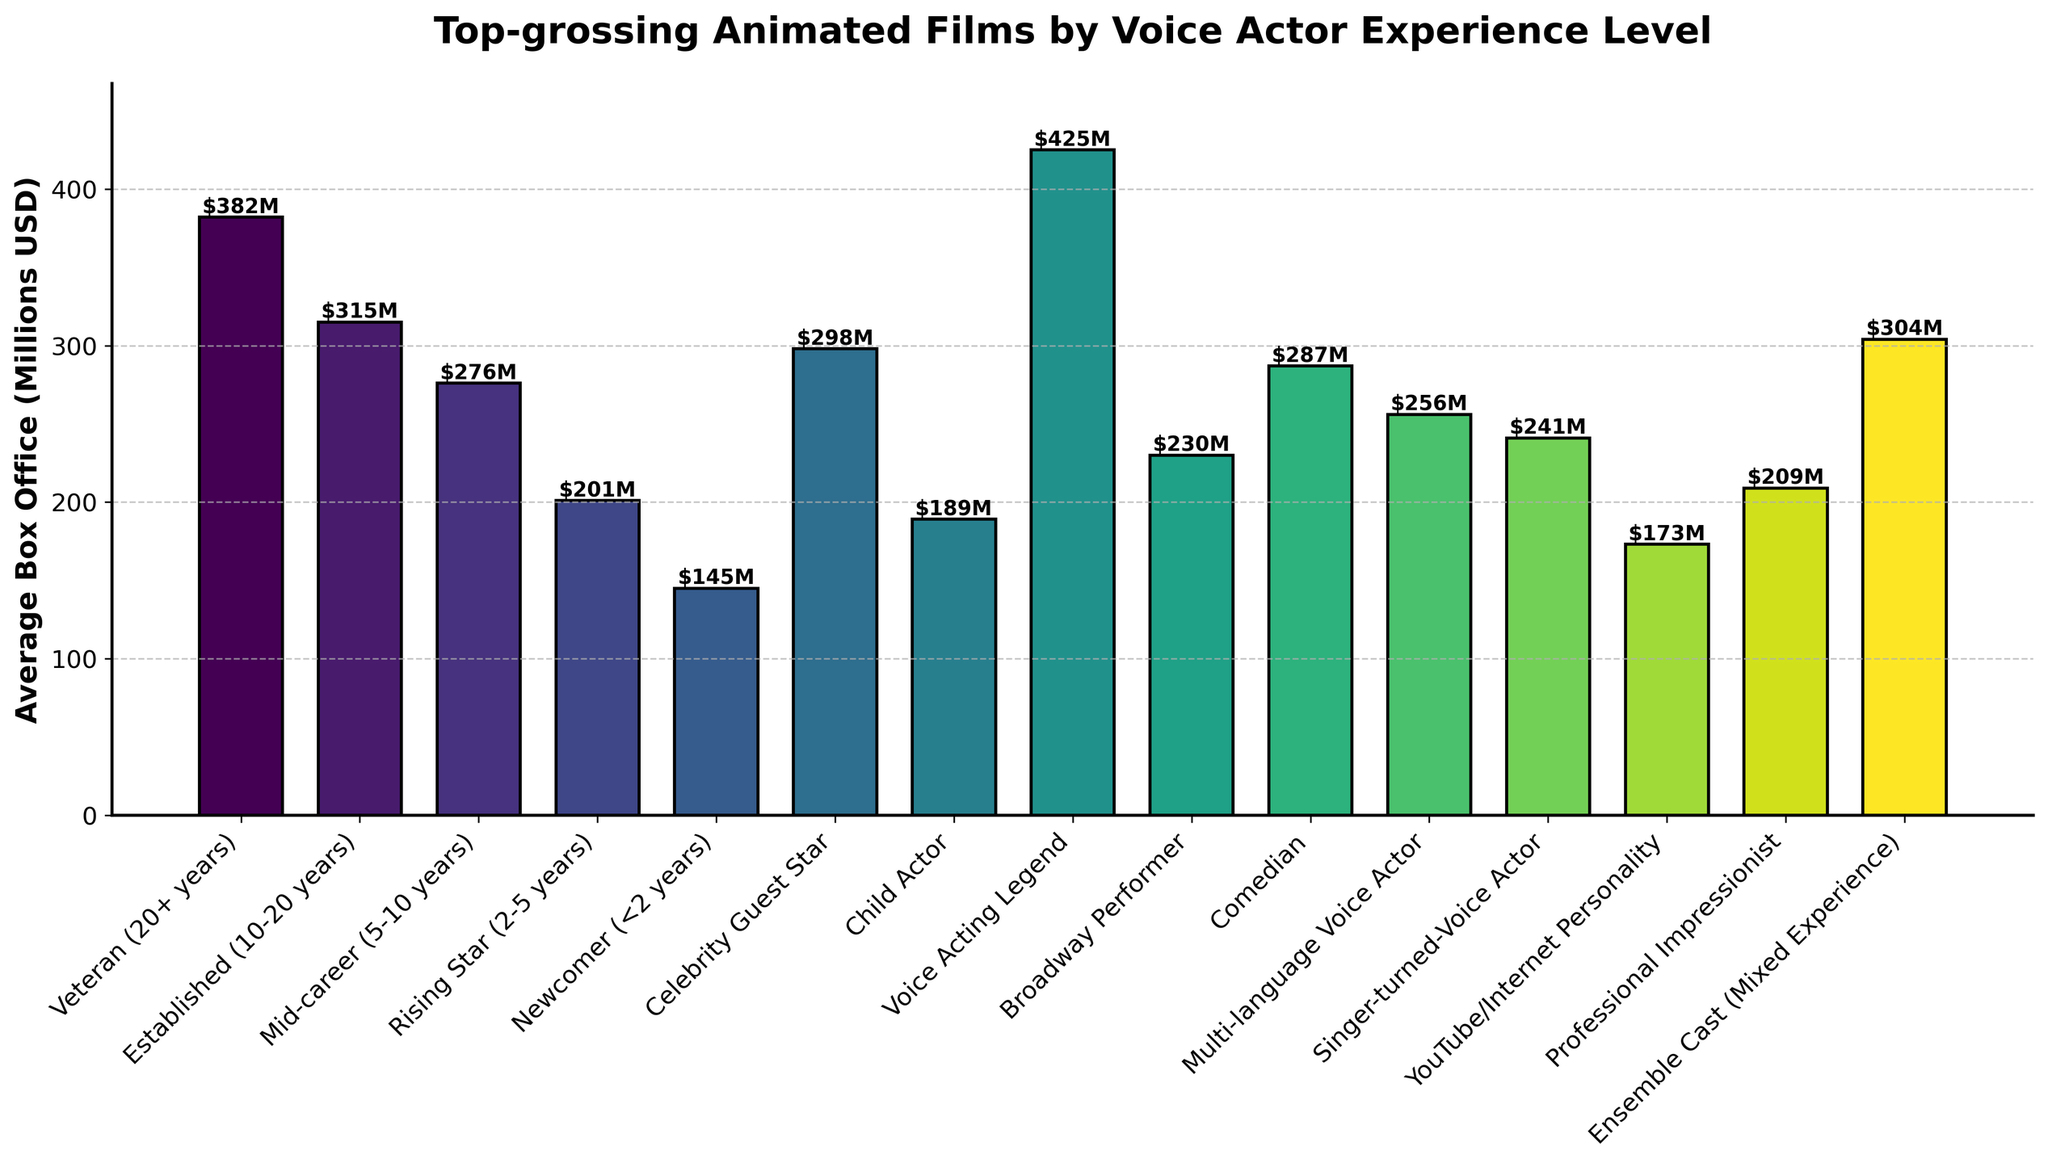Which voice actor experience level has the highest average box office? By examining the heights of the bars, the tallest bar corresponds to the "Voice Acting Legend" category.
Answer: Voice Acting Legend What is the average box office for voice actors with 20+ years of experience versus those under 2 years? The bar for "Veteran (20+ years)" reads $382M and the bar for "Newcomer (<2 years)" reads $145M. Comparing these two values, $382M is greater than $145M.
Answer: Veteran (20+ years): $382M, Newcomer (<2 years): $145M Which category has a higher average box office: Established (10-20 years) or Celebrity Guest Star? The bar for "Established (10-20 years)" reads $315M, and the bar for "Celebrity Guest Star" reads $298M. Comparing these two values, $315M is greater than $298M.
Answer: Established (10-20 years) How much more does a Broadway Performer make on average compared to a YouTube/Internet Personality? The bar for "Broadway Performer" reads $230M, and the bar for "YouTube/Internet Personality" reads $173M. The difference is $230M - $173M.
Answer: $57M Which experience category has a lower average box office than Professional Impressionist but higher than Rising Star (2-5 years)? The bar for "Professional Impressionist" reads $209M, and the bar for "Rising Star (2-5 years)" reads $201M. The category "Broadway Performer" has a value between these two, at $230M.
Answer: None (all bars higher or lower rather than in-between) What is the combined average box office for Child Actor and Comedian categories? The bar for "Child Actor" reads $189M, and the bar for "Comedian" reads $287M. Adding these two values together, $189M + $287M.
Answer: $476M Is the average box office of Multilanguage Voice Actor higher than Singer-turned-Voice Actor? The bar for "Multi-language Voice Actor" reads $256M, and the bar for "Singer-turned-Voice Actor" reads $241M. Comparing these two values, $256M is greater than $241M.
Answer: Yes Which categories have an average box office greater than $300M? The bars for "Voice Acting Legend", "Veteran (20+ years)", "Established (10-20 years)", and "Ensemble Cast (Mixed Experience)" read $425M, $382M, $315M, and $304M respectively, all of which are greater than $300M.
Answer: Voice Acting Legend, Veteran (20+ years), Established (10-20 years), Ensemble Cast (Mixed Experience) How does the average box office of the Rising Star (2-5 years) compare to the Mid-career (5-10 years)? The bar for "Rising Star (2-5 years)" reads $201M, and the bar for "Mid-career (5-10 years)" reads $276M. $201M is less than $276M.
Answer: Less What is the ranking of Professional Impressionist in terms of average box office among all categories? Analyzing the heights of the bars, "Professional Impressionist" at $209M is lower than many categories but higher than a few. They rank below Multifunctional Voice Actor ($256M) but above Child Actor ($189M). Considering the precise order, they seem to be around 9th position based on $209M.
Answer: Approximately 9th 